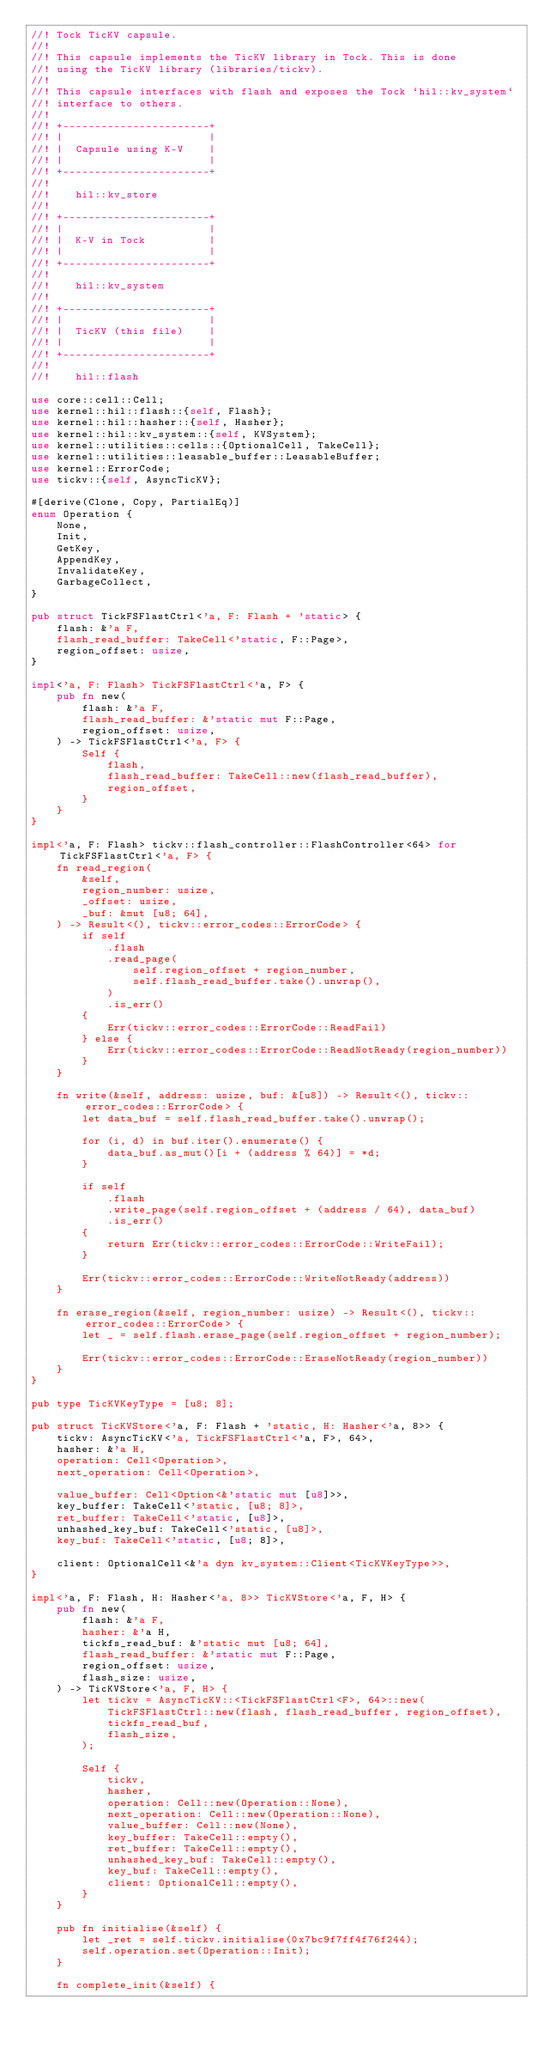<code> <loc_0><loc_0><loc_500><loc_500><_Rust_>//! Tock TicKV capsule.
//!
//! This capsule implements the TicKV library in Tock. This is done
//! using the TicKV library (libraries/tickv).
//!
//! This capsule interfaces with flash and exposes the Tock `hil::kv_system`
//! interface to others.
//!
//! +-----------------------+
//! |                       |
//! |  Capsule using K-V    |
//! |                       |
//! +-----------------------+
//!
//!    hil::kv_store
//!
//! +-----------------------+
//! |                       |
//! |  K-V in Tock          |
//! |                       |
//! +-----------------------+
//!
//!    hil::kv_system
//!
//! +-----------------------+
//! |                       |
//! |  TicKV (this file)    |
//! |                       |
//! +-----------------------+
//!
//!    hil::flash

use core::cell::Cell;
use kernel::hil::flash::{self, Flash};
use kernel::hil::hasher::{self, Hasher};
use kernel::hil::kv_system::{self, KVSystem};
use kernel::utilities::cells::{OptionalCell, TakeCell};
use kernel::utilities::leasable_buffer::LeasableBuffer;
use kernel::ErrorCode;
use tickv::{self, AsyncTicKV};

#[derive(Clone, Copy, PartialEq)]
enum Operation {
    None,
    Init,
    GetKey,
    AppendKey,
    InvalidateKey,
    GarbageCollect,
}

pub struct TickFSFlastCtrl<'a, F: Flash + 'static> {
    flash: &'a F,
    flash_read_buffer: TakeCell<'static, F::Page>,
    region_offset: usize,
}

impl<'a, F: Flash> TickFSFlastCtrl<'a, F> {
    pub fn new(
        flash: &'a F,
        flash_read_buffer: &'static mut F::Page,
        region_offset: usize,
    ) -> TickFSFlastCtrl<'a, F> {
        Self {
            flash,
            flash_read_buffer: TakeCell::new(flash_read_buffer),
            region_offset,
        }
    }
}

impl<'a, F: Flash> tickv::flash_controller::FlashController<64> for TickFSFlastCtrl<'a, F> {
    fn read_region(
        &self,
        region_number: usize,
        _offset: usize,
        _buf: &mut [u8; 64],
    ) -> Result<(), tickv::error_codes::ErrorCode> {
        if self
            .flash
            .read_page(
                self.region_offset + region_number,
                self.flash_read_buffer.take().unwrap(),
            )
            .is_err()
        {
            Err(tickv::error_codes::ErrorCode::ReadFail)
        } else {
            Err(tickv::error_codes::ErrorCode::ReadNotReady(region_number))
        }
    }

    fn write(&self, address: usize, buf: &[u8]) -> Result<(), tickv::error_codes::ErrorCode> {
        let data_buf = self.flash_read_buffer.take().unwrap();

        for (i, d) in buf.iter().enumerate() {
            data_buf.as_mut()[i + (address % 64)] = *d;
        }

        if self
            .flash
            .write_page(self.region_offset + (address / 64), data_buf)
            .is_err()
        {
            return Err(tickv::error_codes::ErrorCode::WriteFail);
        }

        Err(tickv::error_codes::ErrorCode::WriteNotReady(address))
    }

    fn erase_region(&self, region_number: usize) -> Result<(), tickv::error_codes::ErrorCode> {
        let _ = self.flash.erase_page(self.region_offset + region_number);

        Err(tickv::error_codes::ErrorCode::EraseNotReady(region_number))
    }
}

pub type TicKVKeyType = [u8; 8];

pub struct TicKVStore<'a, F: Flash + 'static, H: Hasher<'a, 8>> {
    tickv: AsyncTicKV<'a, TickFSFlastCtrl<'a, F>, 64>,
    hasher: &'a H,
    operation: Cell<Operation>,
    next_operation: Cell<Operation>,

    value_buffer: Cell<Option<&'static mut [u8]>>,
    key_buffer: TakeCell<'static, [u8; 8]>,
    ret_buffer: TakeCell<'static, [u8]>,
    unhashed_key_buf: TakeCell<'static, [u8]>,
    key_buf: TakeCell<'static, [u8; 8]>,

    client: OptionalCell<&'a dyn kv_system::Client<TicKVKeyType>>,
}

impl<'a, F: Flash, H: Hasher<'a, 8>> TicKVStore<'a, F, H> {
    pub fn new(
        flash: &'a F,
        hasher: &'a H,
        tickfs_read_buf: &'static mut [u8; 64],
        flash_read_buffer: &'static mut F::Page,
        region_offset: usize,
        flash_size: usize,
    ) -> TicKVStore<'a, F, H> {
        let tickv = AsyncTicKV::<TickFSFlastCtrl<F>, 64>::new(
            TickFSFlastCtrl::new(flash, flash_read_buffer, region_offset),
            tickfs_read_buf,
            flash_size,
        );

        Self {
            tickv,
            hasher,
            operation: Cell::new(Operation::None),
            next_operation: Cell::new(Operation::None),
            value_buffer: Cell::new(None),
            key_buffer: TakeCell::empty(),
            ret_buffer: TakeCell::empty(),
            unhashed_key_buf: TakeCell::empty(),
            key_buf: TakeCell::empty(),
            client: OptionalCell::empty(),
        }
    }

    pub fn initialise(&self) {
        let _ret = self.tickv.initialise(0x7bc9f7ff4f76f244);
        self.operation.set(Operation::Init);
    }

    fn complete_init(&self) {</code> 